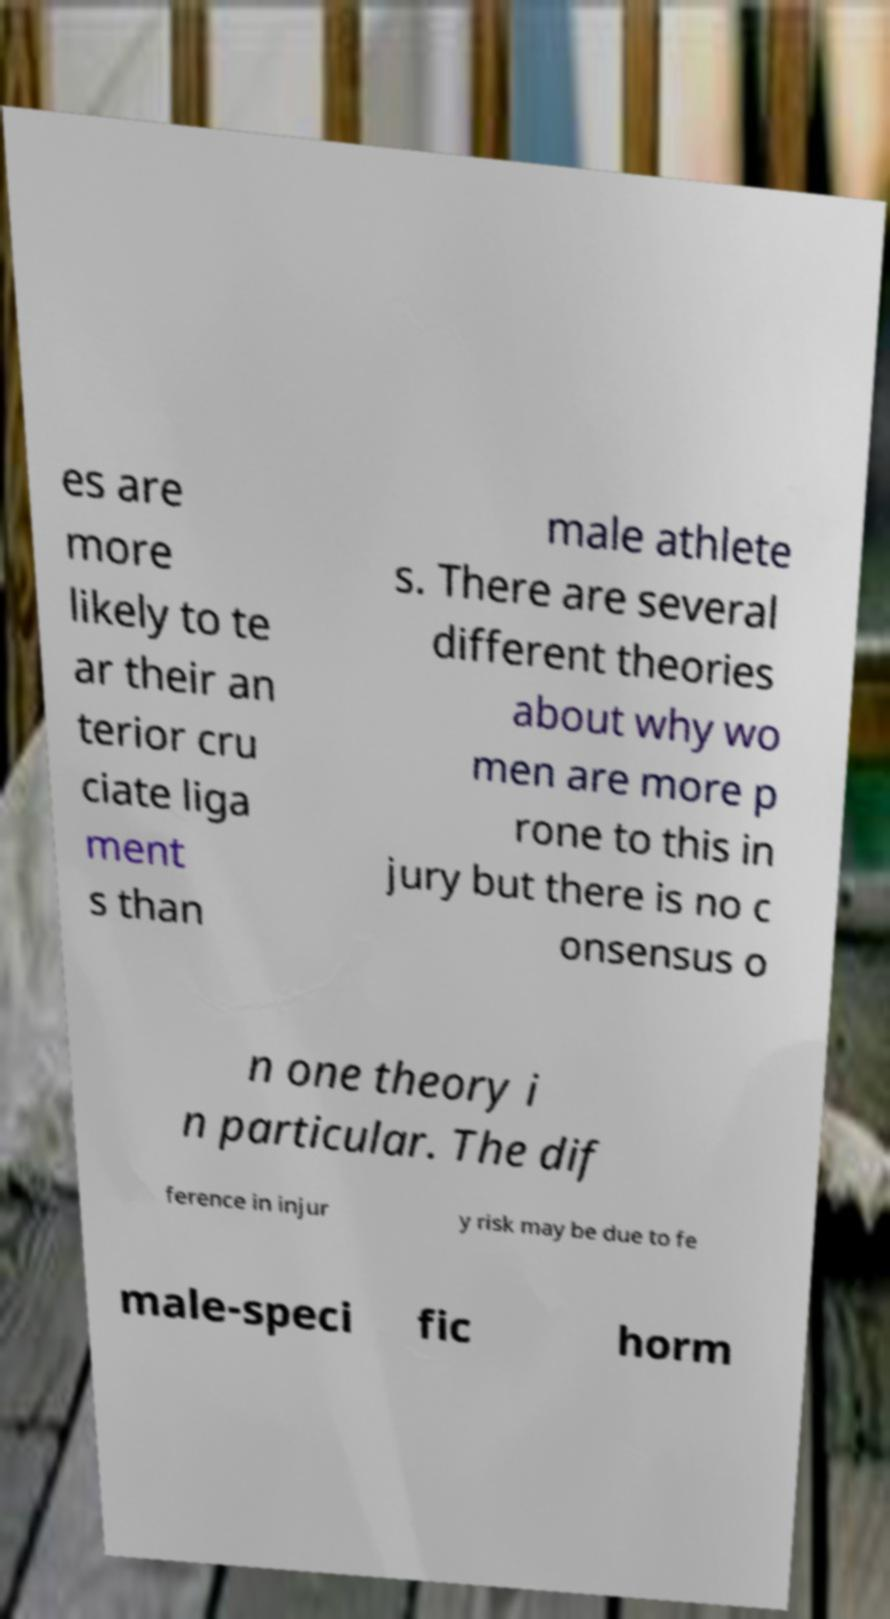Please read and relay the text visible in this image. What does it say? es are more likely to te ar their an terior cru ciate liga ment s than male athlete s. There are several different theories about why wo men are more p rone to this in jury but there is no c onsensus o n one theory i n particular. The dif ference in injur y risk may be due to fe male-speci fic horm 